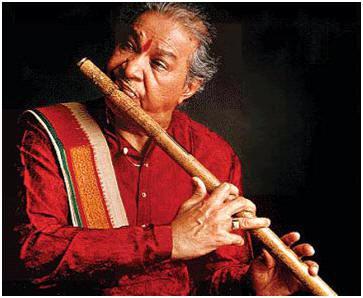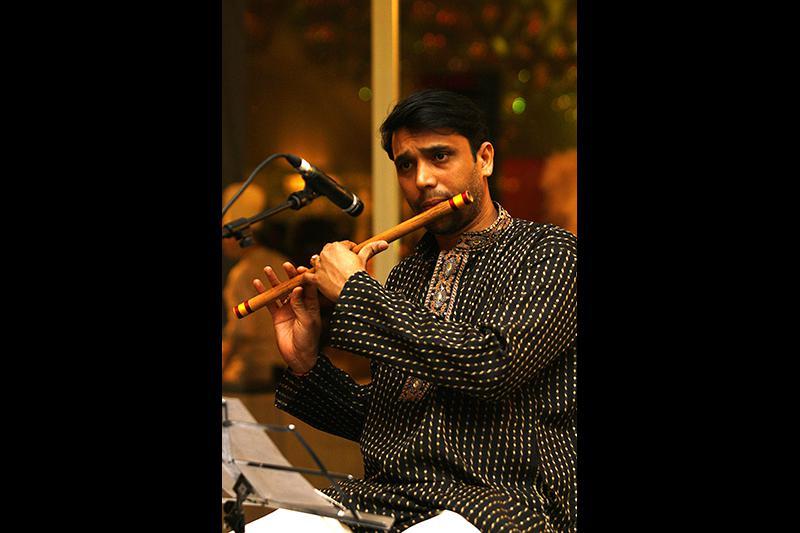The first image is the image on the left, the second image is the image on the right. Given the left and right images, does the statement "a man in a button down shirt with a striped banner on his shoulder is playing a wooden flute" hold true? Answer yes or no. Yes. The first image is the image on the left, the second image is the image on the right. For the images shown, is this caption "The left image contains a man in a red long sleeved shirt playing a musical instrument." true? Answer yes or no. Yes. 